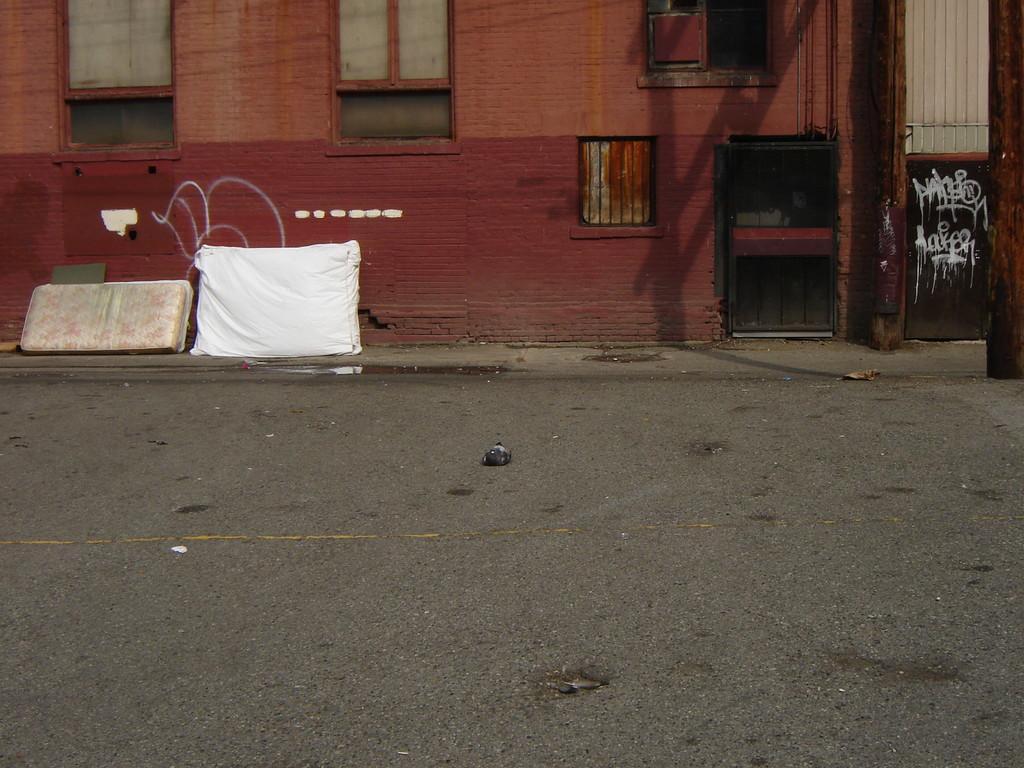Please provide a concise description of this image. In this image I can see a red and brown color building and windows. We can see black color gate. I can see white and cream color objects on the road. 